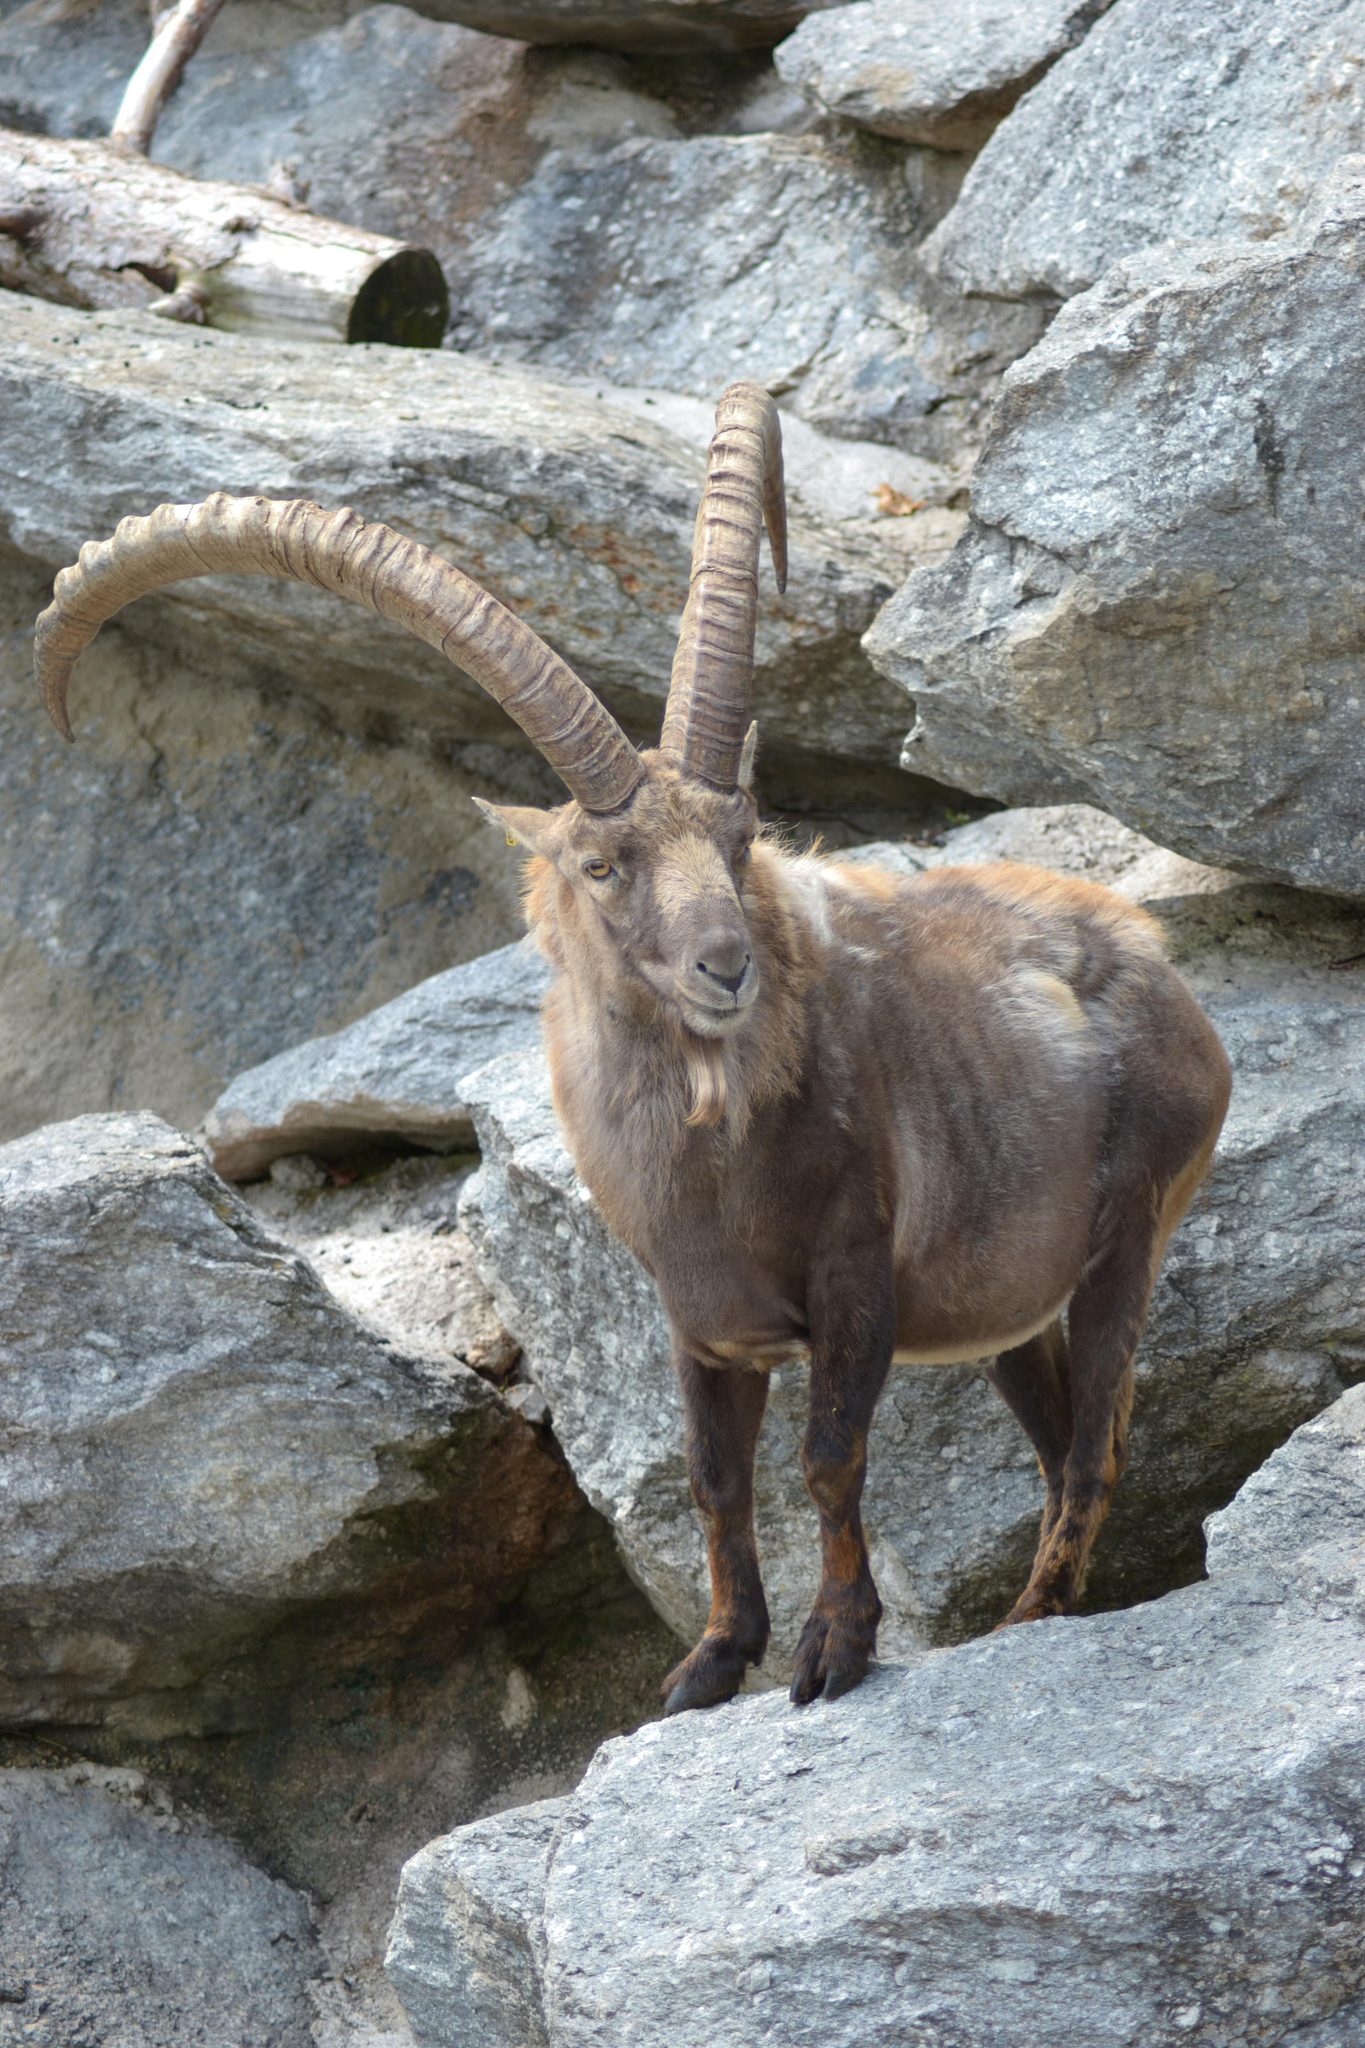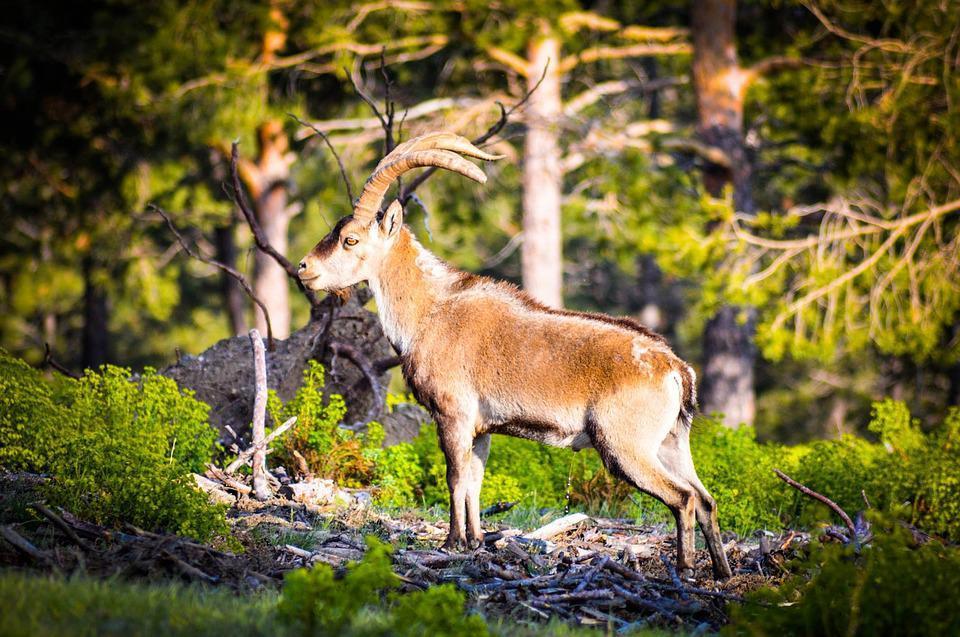The first image is the image on the left, the second image is the image on the right. For the images displayed, is the sentence "An image shows a younger goat standing near an adult goat." factually correct? Answer yes or no. No. 